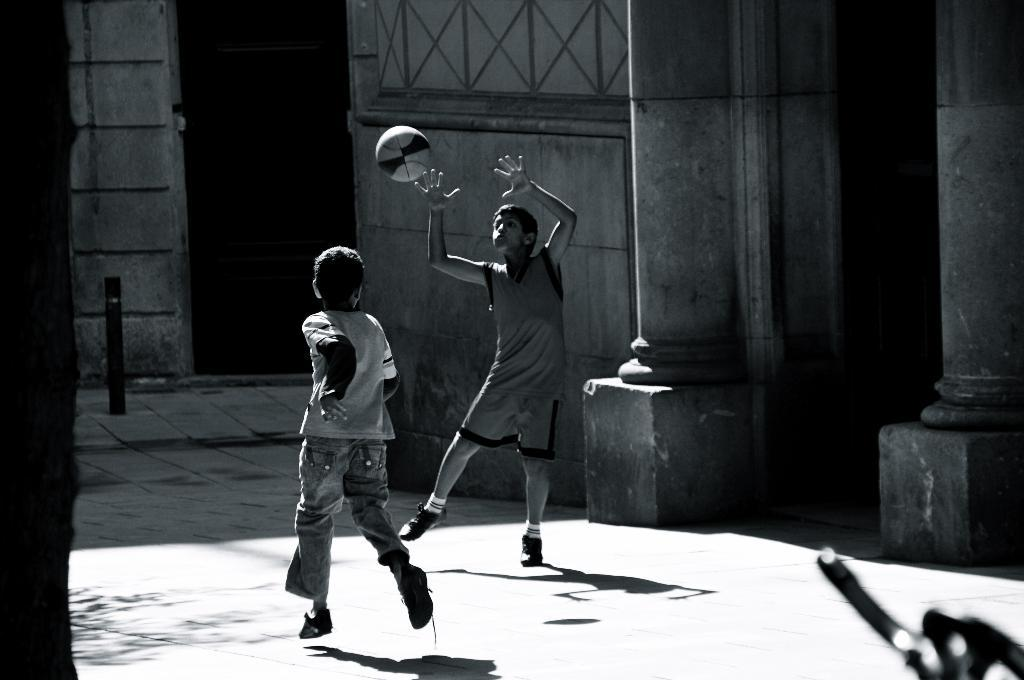How many children are in the image? There are two kids in the image. What are the kids doing in the image? The kids are playing with a ball. What can be seen in the background of the image? There is a building visible in the background of the image. What type of leather material is used to make the dress in the image? There is no dress present in the image, so it is not possible to determine the type of leather material used. 